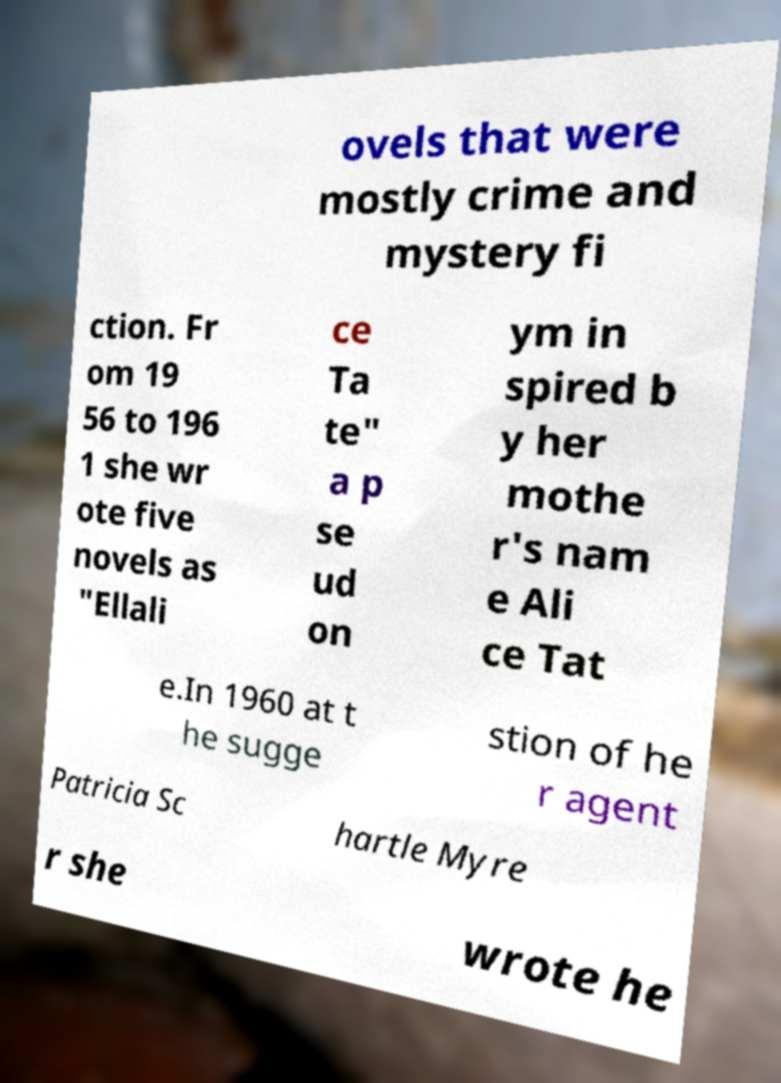There's text embedded in this image that I need extracted. Can you transcribe it verbatim? ovels that were mostly crime and mystery fi ction. Fr om 19 56 to 196 1 she wr ote five novels as "Ellali ce Ta te" a p se ud on ym in spired b y her mothe r's nam e Ali ce Tat e.In 1960 at t he sugge stion of he r agent Patricia Sc hartle Myre r she wrote he 